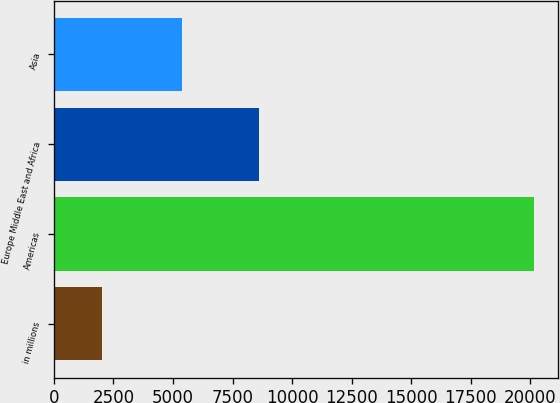Convert chart. <chart><loc_0><loc_0><loc_500><loc_500><bar_chart><fcel>in millions<fcel>Americas<fcel>Europe Middle East and Africa<fcel>Asia<nl><fcel>2012<fcel>20159<fcel>8612<fcel>5392<nl></chart> 